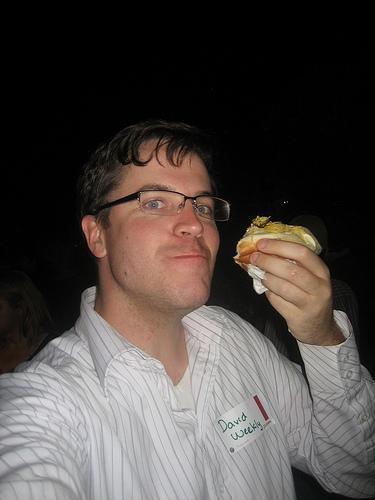How many hands are holding food?
Give a very brief answer. 1. 